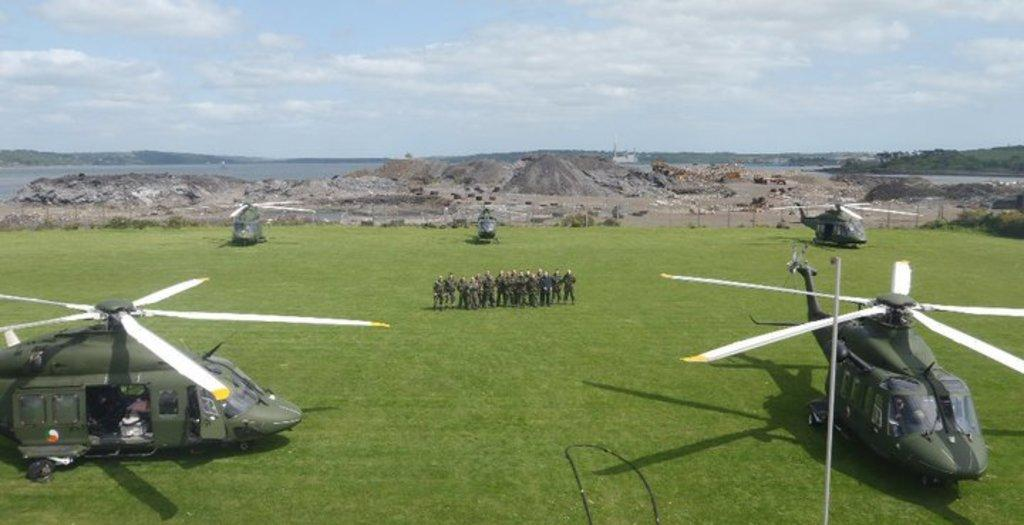What type of vehicles are in the image? There are helicopters in the image. What else can be seen in the image besides the helicopters? There are people on the ground in the image. What is visible in the background of the image? Mountains and sky are visible in the background of the image, along with some unspecified objects. What type of worm can be seen crawling on the helicopter in the image? There is no worm present on the helicopter in the image. What type of beast is visible in the background of the image? There is no beast visible in the background of the image. 